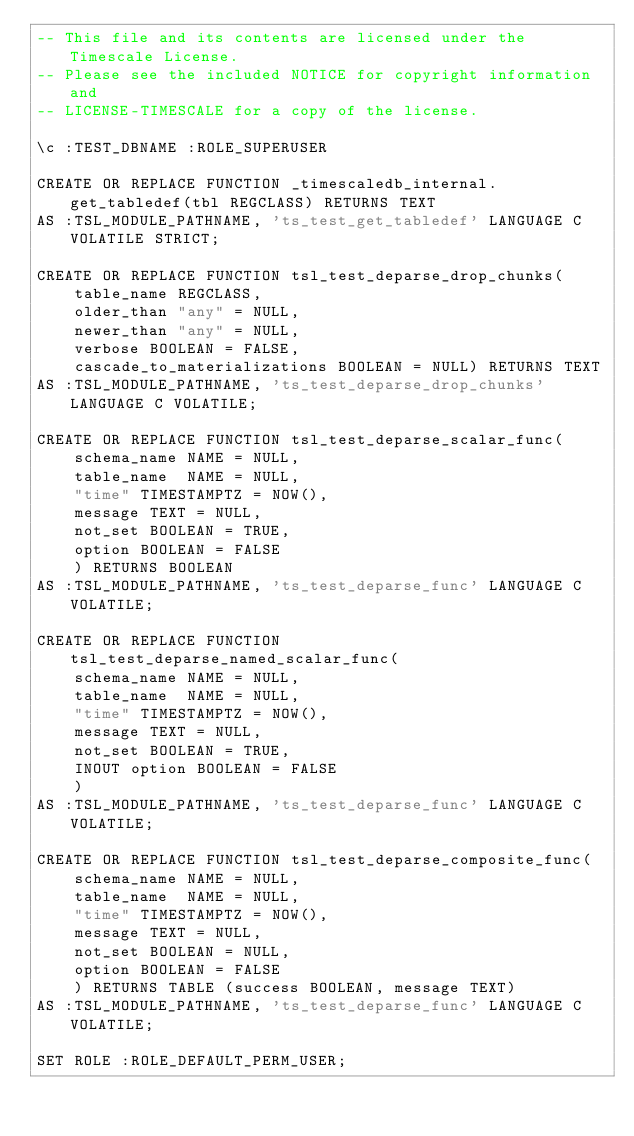<code> <loc_0><loc_0><loc_500><loc_500><_SQL_>-- This file and its contents are licensed under the Timescale License.
-- Please see the included NOTICE for copyright information and
-- LICENSE-TIMESCALE for a copy of the license.

\c :TEST_DBNAME :ROLE_SUPERUSER

CREATE OR REPLACE FUNCTION _timescaledb_internal.get_tabledef(tbl REGCLASS) RETURNS TEXT
AS :TSL_MODULE_PATHNAME, 'ts_test_get_tabledef' LANGUAGE C VOLATILE STRICT;

CREATE OR REPLACE FUNCTION tsl_test_deparse_drop_chunks(
    table_name REGCLASS,
    older_than "any" = NULL,
    newer_than "any" = NULL,
    verbose BOOLEAN = FALSE,
    cascade_to_materializations BOOLEAN = NULL) RETURNS TEXT
AS :TSL_MODULE_PATHNAME, 'ts_test_deparse_drop_chunks' LANGUAGE C VOLATILE;

CREATE OR REPLACE FUNCTION tsl_test_deparse_scalar_func(
    schema_name NAME = NULL,
    table_name  NAME = NULL,
    "time" TIMESTAMPTZ = NOW(),
    message TEXT = NULL,
    not_set BOOLEAN = TRUE,
    option BOOLEAN = FALSE
    ) RETURNS BOOLEAN
AS :TSL_MODULE_PATHNAME, 'ts_test_deparse_func' LANGUAGE C VOLATILE;

CREATE OR REPLACE FUNCTION tsl_test_deparse_named_scalar_func(
    schema_name NAME = NULL,
    table_name  NAME = NULL,
    "time" TIMESTAMPTZ = NOW(),
    message TEXT = NULL,
    not_set BOOLEAN = TRUE,
    INOUT option BOOLEAN = FALSE
    )
AS :TSL_MODULE_PATHNAME, 'ts_test_deparse_func' LANGUAGE C VOLATILE;

CREATE OR REPLACE FUNCTION tsl_test_deparse_composite_func(
    schema_name NAME = NULL,
    table_name  NAME = NULL,
    "time" TIMESTAMPTZ = NOW(),
    message TEXT = NULL,
    not_set BOOLEAN = NULL,
    option BOOLEAN = FALSE
    ) RETURNS TABLE (success BOOLEAN, message TEXT)
AS :TSL_MODULE_PATHNAME, 'ts_test_deparse_func' LANGUAGE C VOLATILE;

SET ROLE :ROLE_DEFAULT_PERM_USER;
</code> 